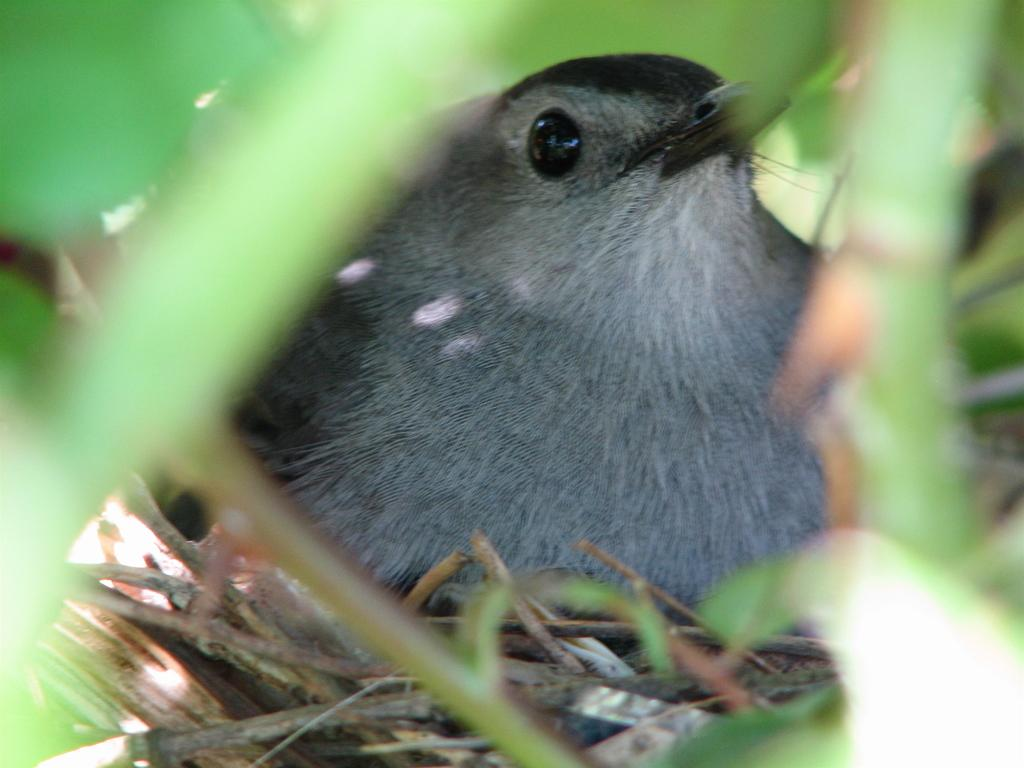What can be seen in the foreground of the image? There is a bird in a nest in the foreground. What is surrounding the nest in the image? There are leaves visible around the nest. What type of society is depicted in the image? There is no society depicted in the image; it features a bird in a nest surrounded by leaves. What kind of trouble is the bird facing in the image? There is no indication of trouble for the bird in the image; it is simply sitting in its nest. 